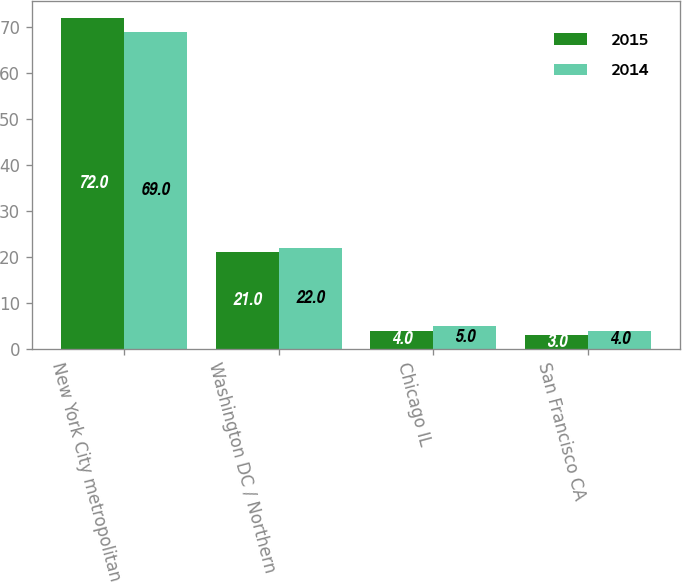Convert chart. <chart><loc_0><loc_0><loc_500><loc_500><stacked_bar_chart><ecel><fcel>New York City metropolitan<fcel>Washington DC / Northern<fcel>Chicago IL<fcel>San Francisco CA<nl><fcel>2015<fcel>72<fcel>21<fcel>4<fcel>3<nl><fcel>2014<fcel>69<fcel>22<fcel>5<fcel>4<nl></chart> 